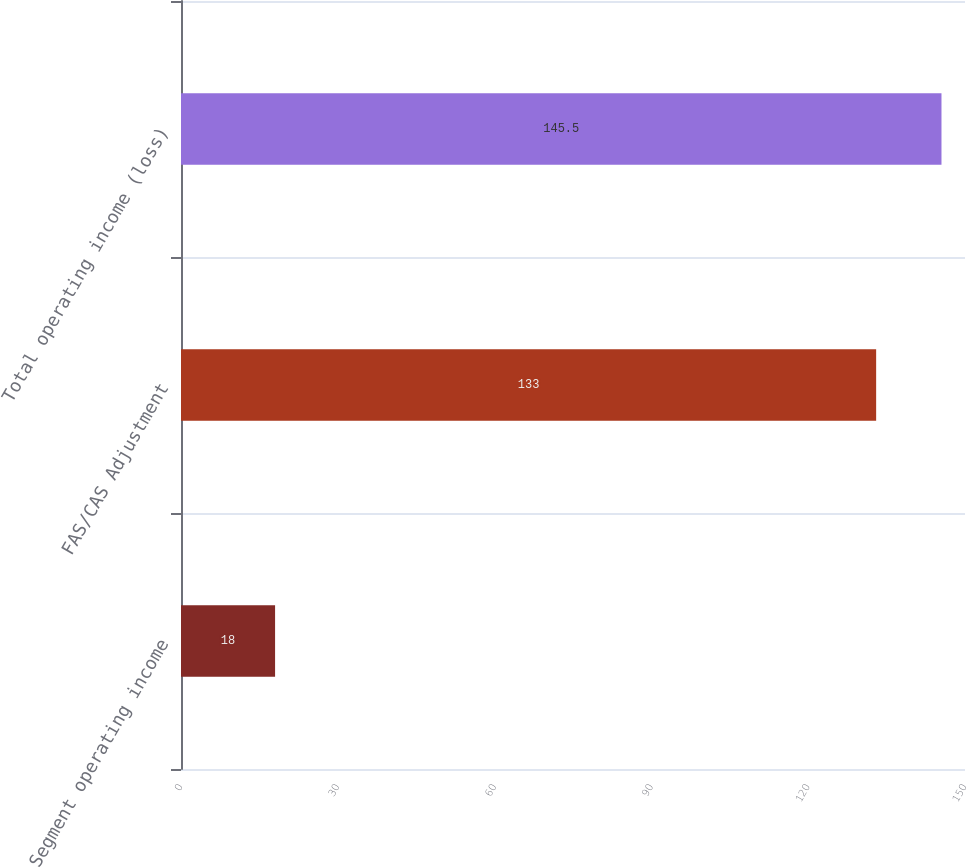Convert chart. <chart><loc_0><loc_0><loc_500><loc_500><bar_chart><fcel>Segment operating income<fcel>FAS/CAS Adjustment<fcel>Total operating income (loss)<nl><fcel>18<fcel>133<fcel>145.5<nl></chart> 